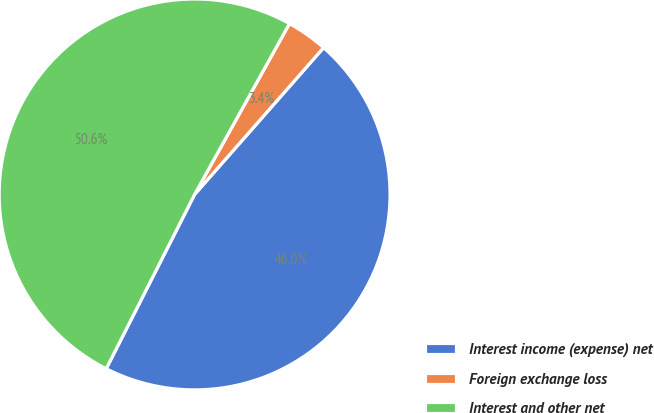<chart> <loc_0><loc_0><loc_500><loc_500><pie_chart><fcel>Interest income (expense) net<fcel>Foreign exchange loss<fcel>Interest and other net<nl><fcel>46.0%<fcel>3.41%<fcel>50.6%<nl></chart> 